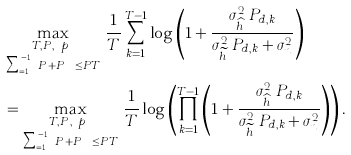Convert formula to latex. <formula><loc_0><loc_0><loc_500><loc_500>& \max _ { \substack { T , P _ { t } , \ p _ { d } \\ \sum _ { k = 1 } ^ { T - 1 } P _ { t } + P _ { d , k } \leq P T } } \, \frac { 1 } { T } \sum _ { k = 1 } ^ { T - 1 } \log \left ( 1 + \frac { \sigma _ { \widehat { h } _ { k } } ^ { 2 } P _ { d , k } } { \sigma _ { \widetilde { h } _ { k } } ^ { 2 } P _ { d , k } + \sigma _ { n } ^ { 2 } } \right ) \\ & = \max _ { \substack { T , P _ { t } , \ p _ { d } \\ \sum _ { k = 1 } ^ { T - 1 } P _ { t } + P _ { d , k } \leq P T } } \, \frac { 1 } { T } \log \left ( \prod _ { k = 1 } ^ { T - 1 } \left ( 1 + \frac { \sigma _ { \widehat { h } _ { k } } ^ { 2 } P _ { d , k } } { \sigma _ { \widetilde { h } _ { k } } ^ { 2 } P _ { d , k } + \sigma _ { n } ^ { 2 } } \right ) \right ) .</formula> 